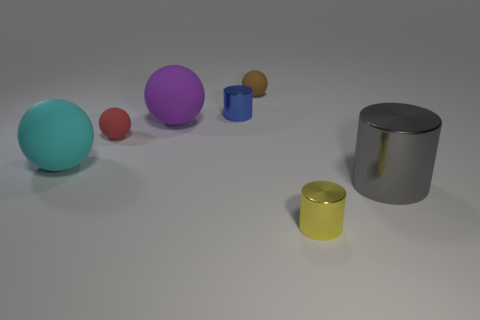Subtract all tiny metal cylinders. How many cylinders are left? 1 Add 1 tiny shiny cubes. How many objects exist? 8 Subtract 1 cylinders. How many cylinders are left? 2 Subtract all yellow cylinders. How many cylinders are left? 2 Subtract all spheres. How many objects are left? 3 Add 7 tiny yellow objects. How many tiny yellow objects are left? 8 Add 7 small cyan rubber blocks. How many small cyan rubber blocks exist? 7 Subtract 0 yellow balls. How many objects are left? 7 Subtract all green cylinders. Subtract all gray blocks. How many cylinders are left? 3 Subtract all shiny cylinders. Subtract all big red cylinders. How many objects are left? 4 